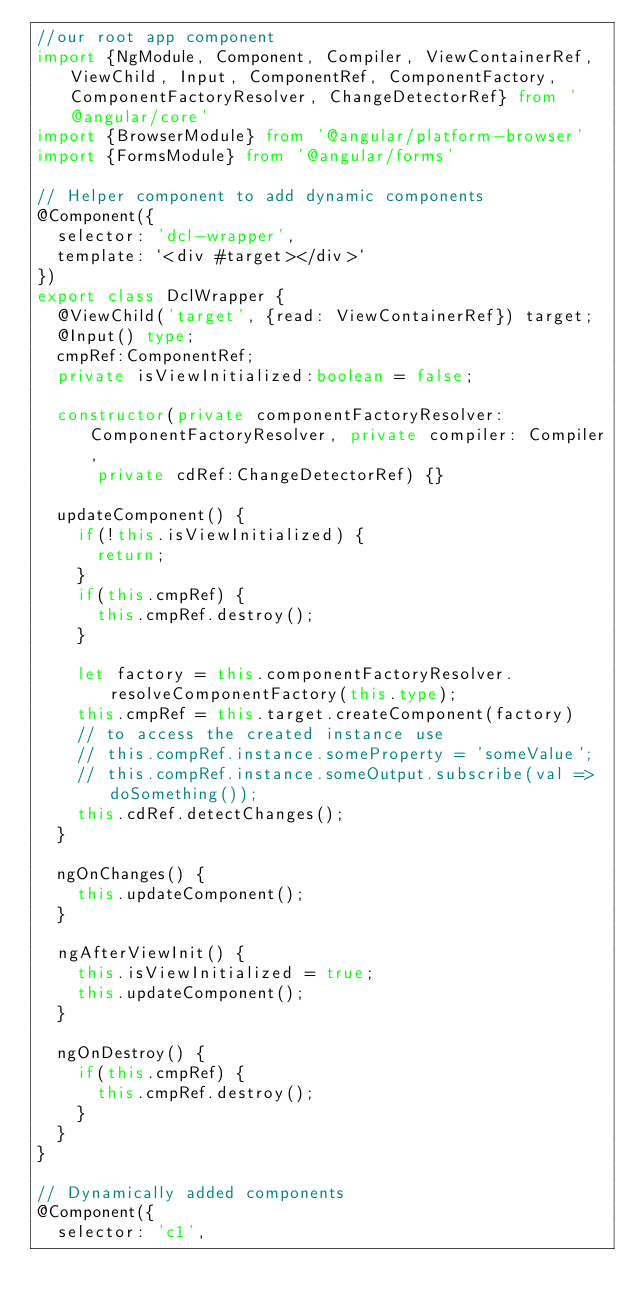<code> <loc_0><loc_0><loc_500><loc_500><_TypeScript_>//our root app component
import {NgModule, Component, Compiler, ViewContainerRef, ViewChild, Input, ComponentRef, ComponentFactory, ComponentFactoryResolver, ChangeDetectorRef} from '@angular/core'
import {BrowserModule} from '@angular/platform-browser'
import {FormsModule} from '@angular/forms'

// Helper component to add dynamic components
@Component({
  selector: 'dcl-wrapper',
  template: `<div #target></div>`
})
export class DclWrapper {
  @ViewChild('target', {read: ViewContainerRef}) target;
  @Input() type;
  cmpRef:ComponentRef;
  private isViewInitialized:boolean = false;
  
  constructor(private componentFactoryResolver: ComponentFactoryResolver, private compiler: Compiler,
      private cdRef:ChangeDetectorRef) {}

  updateComponent() {
    if(!this.isViewInitialized) {
      return;
    }
    if(this.cmpRef) {
      this.cmpRef.destroy();
    }

    let factory = this.componentFactoryResolver.resolveComponentFactory(this.type);
    this.cmpRef = this.target.createComponent(factory)
    // to access the created instance use
    // this.compRef.instance.someProperty = 'someValue';
    // this.compRef.instance.someOutput.subscribe(val => doSomething());
    this.cdRef.detectChanges();
  }
  
  ngOnChanges() {
    this.updateComponent();
  }
  
  ngAfterViewInit() {
    this.isViewInitialized = true;
    this.updateComponent();  
  }
  
  ngOnDestroy() {
    if(this.cmpRef) {
      this.cmpRef.destroy();
    }    
  }
}

// Dynamically added components
@Component({
  selector: 'c1',</code> 